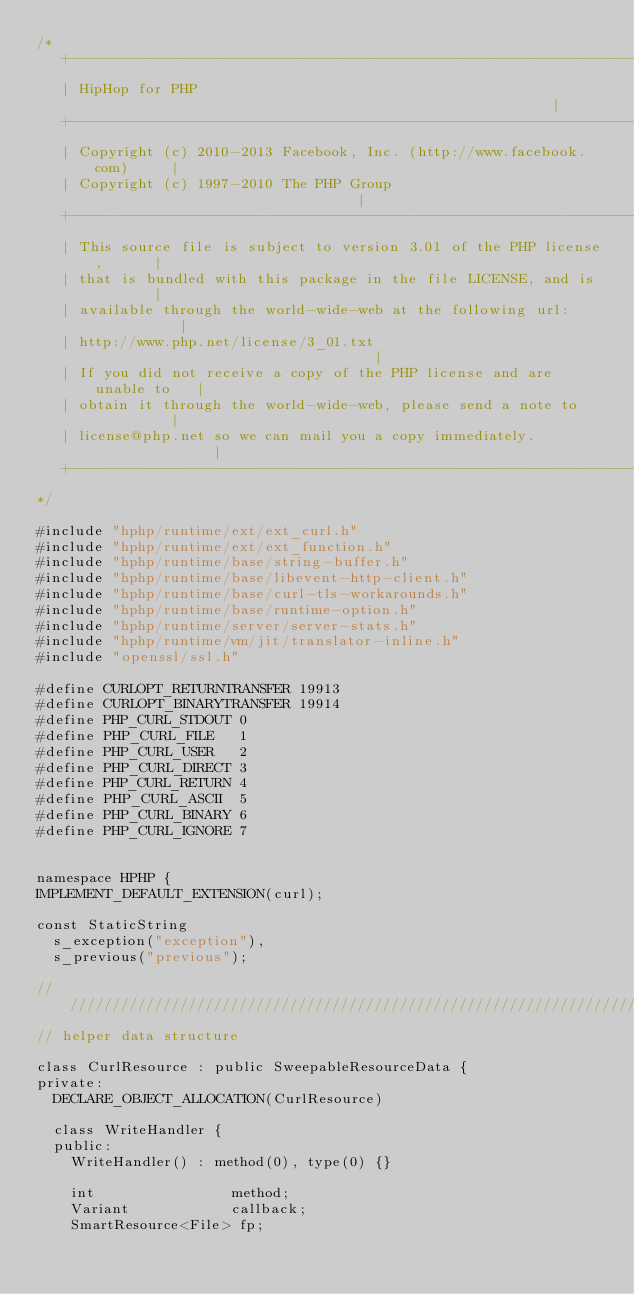<code> <loc_0><loc_0><loc_500><loc_500><_C++_>/*
   +----------------------------------------------------------------------+
   | HipHop for PHP                                                       |
   +----------------------------------------------------------------------+
   | Copyright (c) 2010-2013 Facebook, Inc. (http://www.facebook.com)     |
   | Copyright (c) 1997-2010 The PHP Group                                |
   +----------------------------------------------------------------------+
   | This source file is subject to version 3.01 of the PHP license,      |
   | that is bundled with this package in the file LICENSE, and is        |
   | available through the world-wide-web at the following url:           |
   | http://www.php.net/license/3_01.txt                                  |
   | If you did not receive a copy of the PHP license and are unable to   |
   | obtain it through the world-wide-web, please send a note to          |
   | license@php.net so we can mail you a copy immediately.               |
   +----------------------------------------------------------------------+
*/

#include "hphp/runtime/ext/ext_curl.h"
#include "hphp/runtime/ext/ext_function.h"
#include "hphp/runtime/base/string-buffer.h"
#include "hphp/runtime/base/libevent-http-client.h"
#include "hphp/runtime/base/curl-tls-workarounds.h"
#include "hphp/runtime/base/runtime-option.h"
#include "hphp/runtime/server/server-stats.h"
#include "hphp/runtime/vm/jit/translator-inline.h"
#include "openssl/ssl.h"

#define CURLOPT_RETURNTRANSFER 19913
#define CURLOPT_BINARYTRANSFER 19914
#define PHP_CURL_STDOUT 0
#define PHP_CURL_FILE   1
#define PHP_CURL_USER   2
#define PHP_CURL_DIRECT 3
#define PHP_CURL_RETURN 4
#define PHP_CURL_ASCII  5
#define PHP_CURL_BINARY 6
#define PHP_CURL_IGNORE 7


namespace HPHP {
IMPLEMENT_DEFAULT_EXTENSION(curl);

const StaticString
  s_exception("exception"),
  s_previous("previous");

///////////////////////////////////////////////////////////////////////////////
// helper data structure

class CurlResource : public SweepableResourceData {
private:
  DECLARE_OBJECT_ALLOCATION(CurlResource)

  class WriteHandler {
  public:
    WriteHandler() : method(0), type(0) {}

    int                method;
    Variant            callback;
    SmartResource<File> fp;</code> 